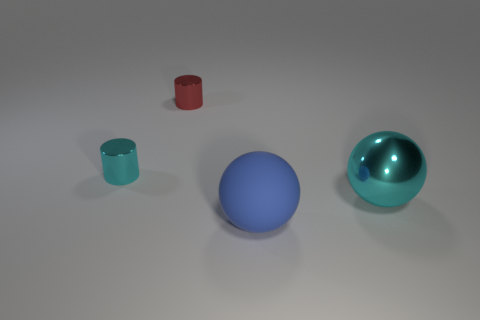There is a cyan cylinder that is the same size as the red thing; what material is it?
Keep it short and to the point. Metal. How many objects are tiny cyan objects or big spheres that are behind the blue rubber ball?
Give a very brief answer. 2. There is another cylinder that is the same material as the cyan cylinder; what is its size?
Give a very brief answer. Small. There is a cyan thing on the left side of the thing that is on the right side of the large blue ball; what is its shape?
Give a very brief answer. Cylinder. There is a metal object that is both right of the small cyan thing and on the left side of the big rubber thing; how big is it?
Give a very brief answer. Small. Are there any other cyan things that have the same shape as the large rubber object?
Provide a succinct answer. Yes. What material is the cyan thing to the left of the cyan object to the right of the small metal object that is behind the small cyan object made of?
Provide a short and direct response. Metal. Is there a cyan thing that has the same size as the red cylinder?
Make the answer very short. Yes. There is a small cylinder right of the cyan metal object that is behind the big metal sphere; what is its color?
Your answer should be very brief. Red. What number of small purple objects are there?
Your answer should be compact. 0. 